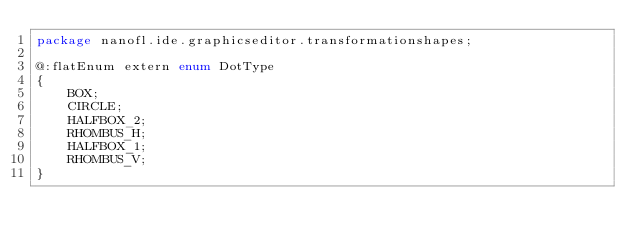<code> <loc_0><loc_0><loc_500><loc_500><_Haxe_>package nanofl.ide.graphicseditor.transformationshapes;

@:flatEnum extern enum DotType
{
	BOX;
	CIRCLE;
	HALFBOX_2;
	RHOMBUS_H;
	HALFBOX_1;
	RHOMBUS_V;
}</code> 